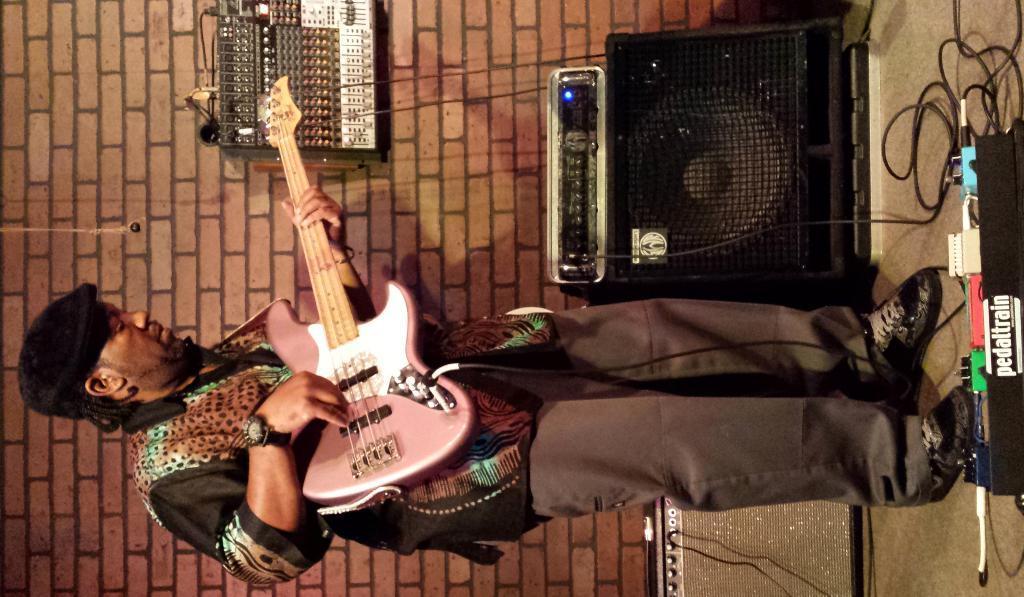In one or two sentences, can you explain what this image depicts? In this picture we can see a man is standing and playing a guitar, we can see an amplifier, a speaker and some wires on the right side, there is an audio controller in the middle, in the background there is a wall. 